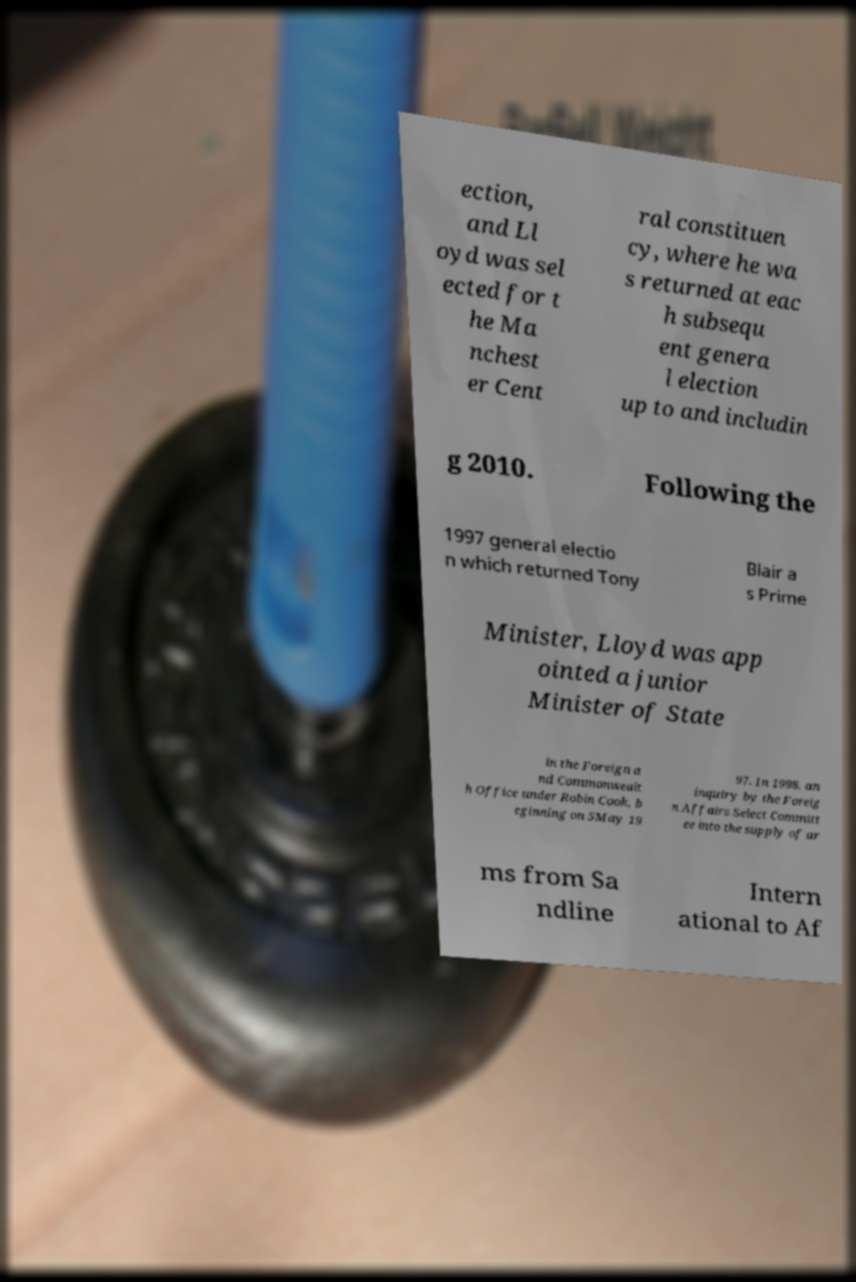Please read and relay the text visible in this image. What does it say? ection, and Ll oyd was sel ected for t he Ma nchest er Cent ral constituen cy, where he wa s returned at eac h subsequ ent genera l election up to and includin g 2010. Following the 1997 general electio n which returned Tony Blair a s Prime Minister, Lloyd was app ointed a junior Minister of State in the Foreign a nd Commonwealt h Office under Robin Cook, b eginning on 5May 19 97. In 1998, an inquiry by the Foreig n Affairs Select Committ ee into the supply of ar ms from Sa ndline Intern ational to Af 